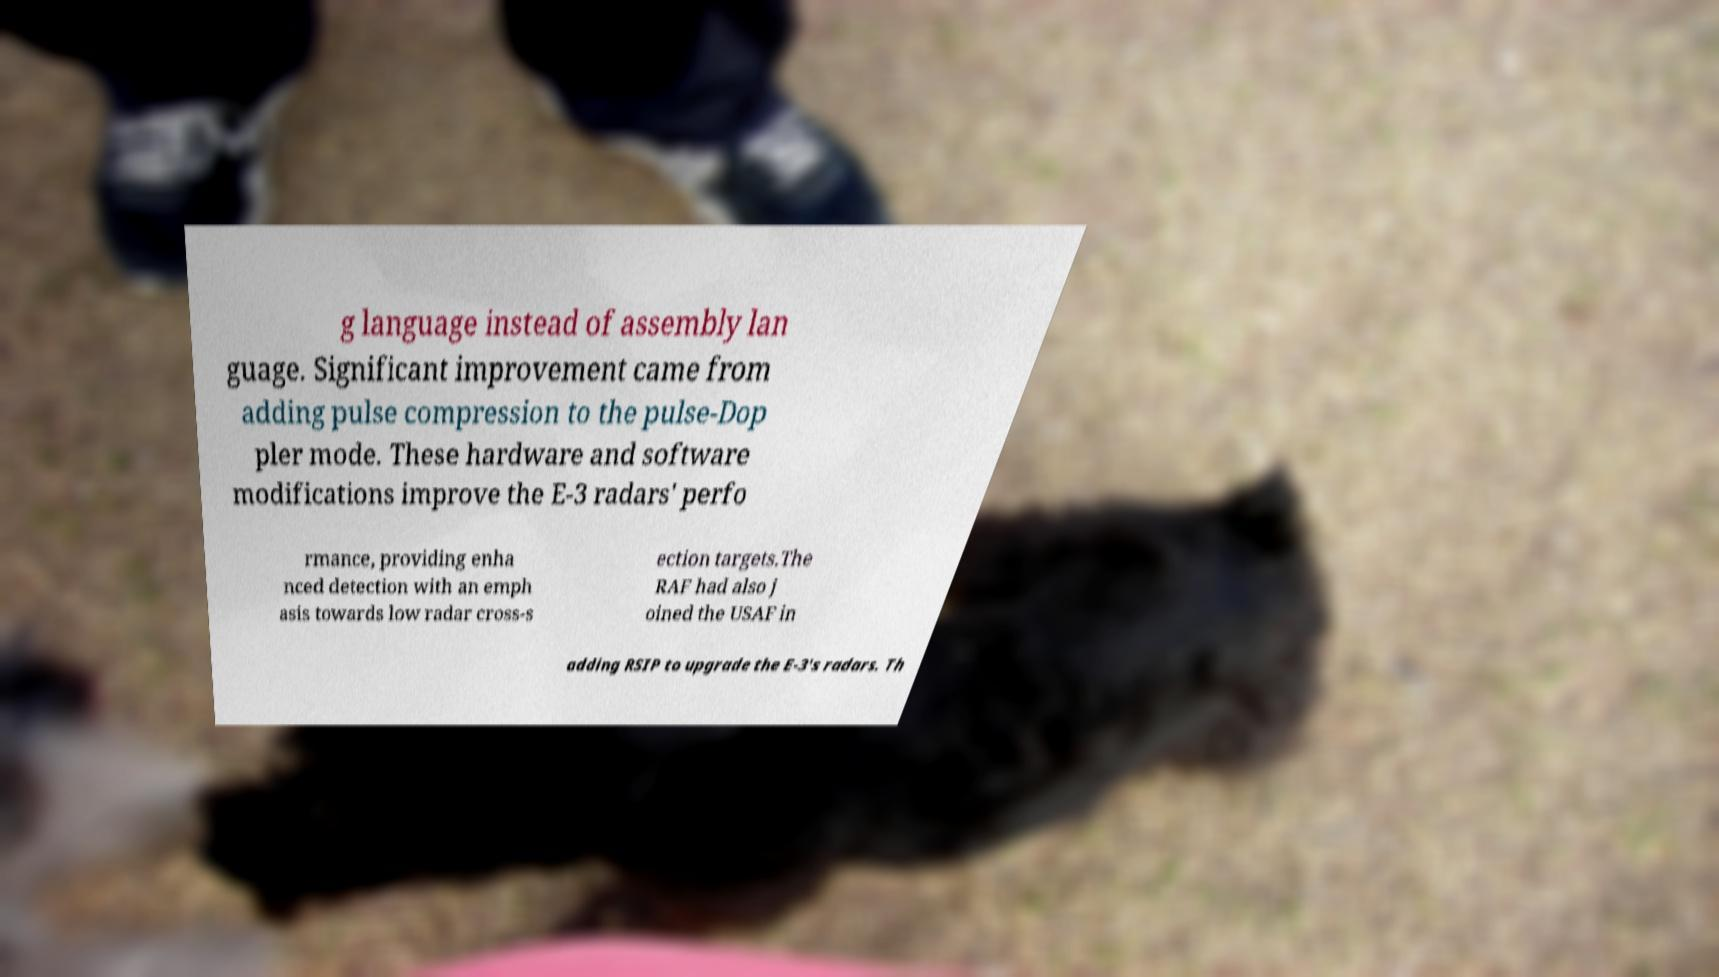Could you assist in decoding the text presented in this image and type it out clearly? g language instead of assembly lan guage. Significant improvement came from adding pulse compression to the pulse-Dop pler mode. These hardware and software modifications improve the E-3 radars' perfo rmance, providing enha nced detection with an emph asis towards low radar cross-s ection targets.The RAF had also j oined the USAF in adding RSIP to upgrade the E-3's radars. Th 